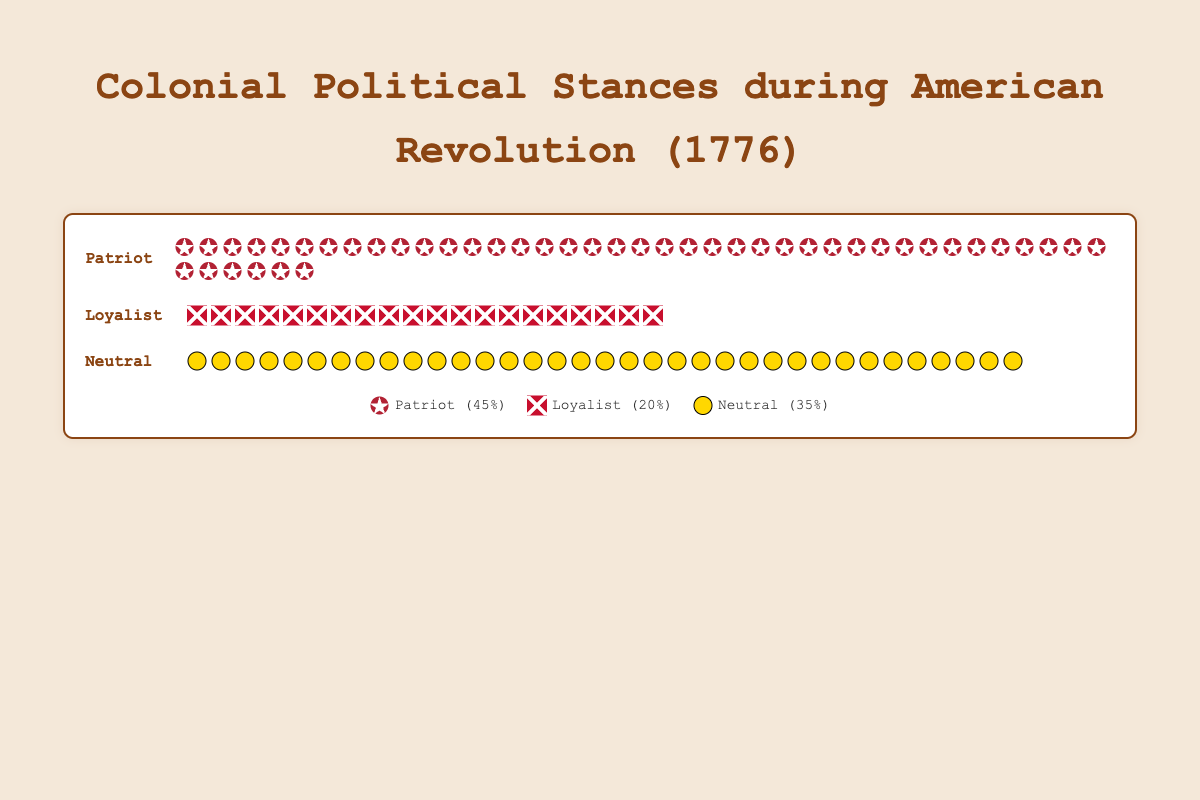What are the three main political stances represented in the figure? The figure shows three main political stances represented with different icons. They are labeled as Patriot, Loyalist, and Neutral.
Answer: Patriot, Loyalist, Neutral How many icons represent the Loyalist stance? By counting the icons under the Loyalist section, we can see there are 20 icons representing the Loyalist stance.
Answer: 20 What percentage of the total colonial population in 1776 supported the Patriot stance? The Patriot stance is represented by 45 icons, which matches 45% of the total population according to the legend.
Answer: 45% What is the total number of people who supported the Loyalist stance in 1776? As per the figure's data, 20% of the total 2,500,000 population supported the Loyalist stance. Therefore, 20% of 2,500,000 equals 500,000 people.
Answer: 500,000 Which region had the highest percentage of Patriots? According to the data, New England had the highest Patriot percentage at 60%.
Answer: New England How many more people were Patriots compared to Loyalists? The counts given indicate there were 1,125,000 Patriots and 500,000 Loyalists. The difference is 1,125,000 - 500,000.
Answer: 625,000 Which political stance had the least support? The stance with the fewest icons in the figure is the Loyalist stance, represented by 20% of the population.
Answer: Loyalist What is the combined percentage of the population that was not neutral? The figure states that 45% were Patriots and 20% were Loyalists. Adding these together gives the combined percentage.
Answer: 65% What percentage of the Southern Colonies supported the Patriot stance? According to the regional data, the Southern Colonies had 35% of their population supporting the Patriot stance.
Answer: 35% If you add up the percentages of Patriots in all regions, what is the total? New England has 60%, Middle Colonies have 40%, and Southern Colonies have 35%. Adding these together gives us the total.
Answer: 135% 